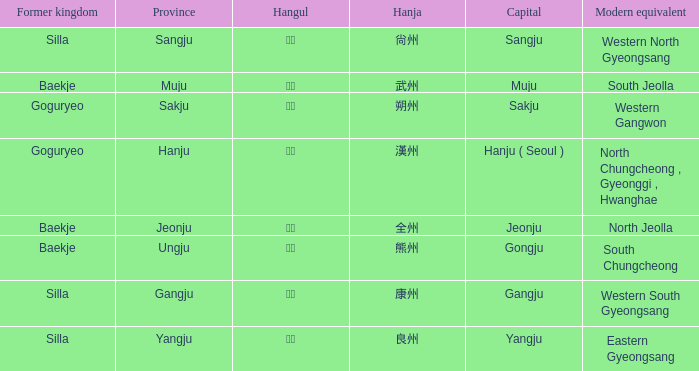What is the hangul symbol for the hanja 良州? 양주. 